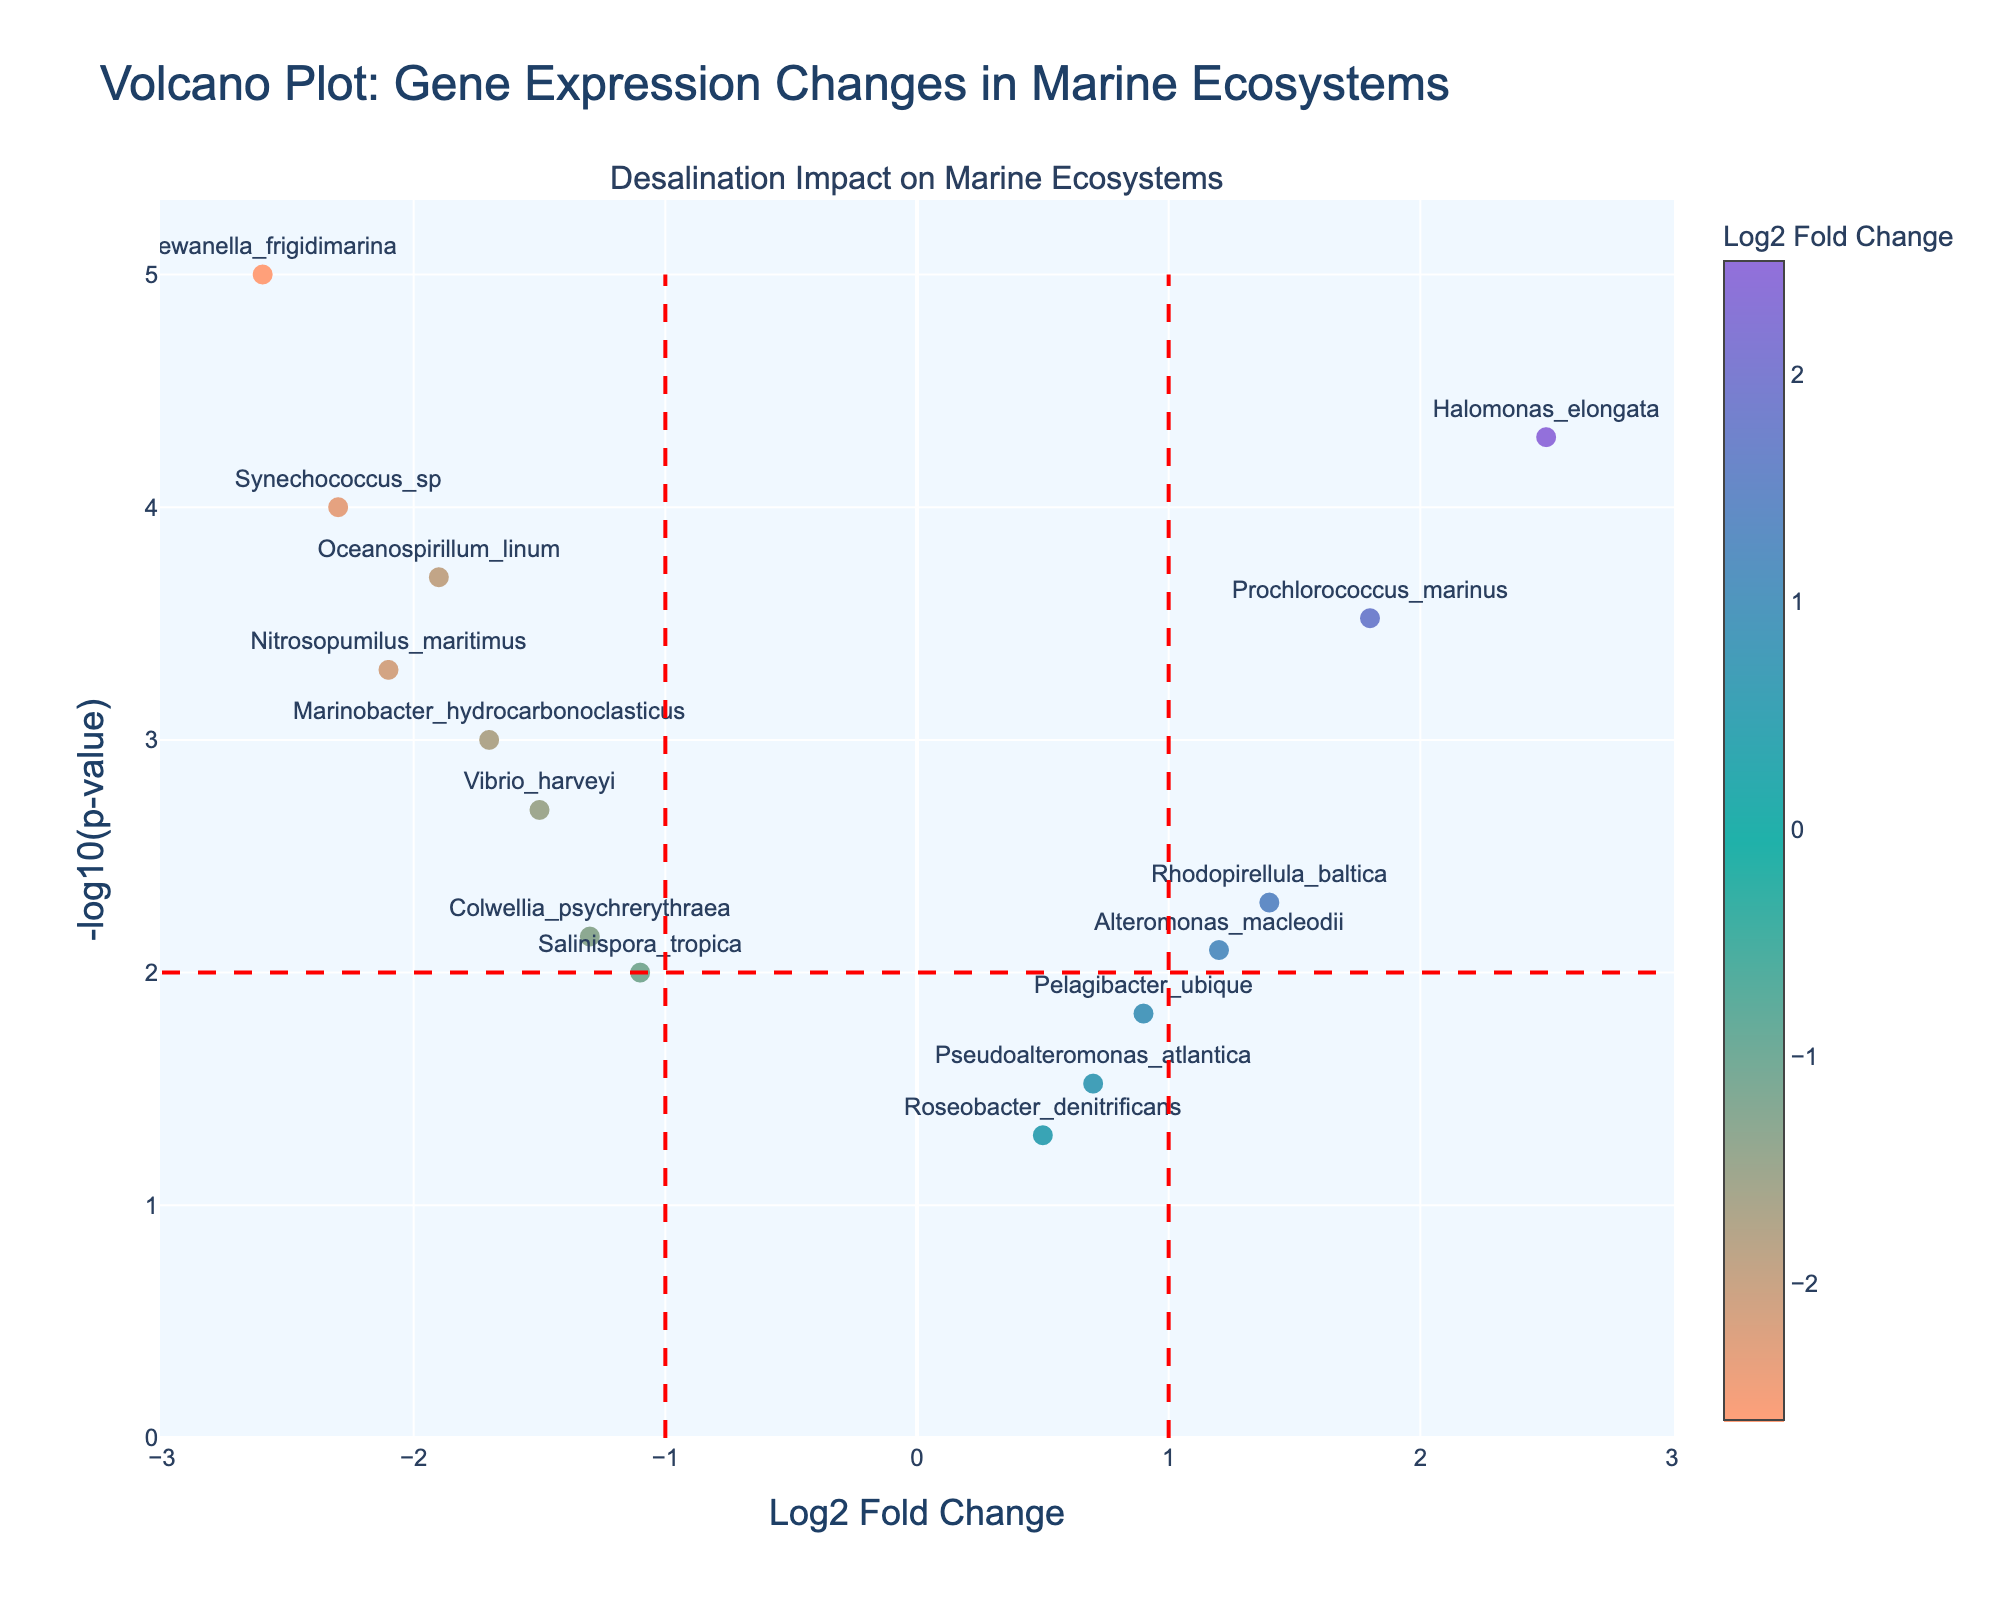How many genes show significant change (p-value < 0.05)? Count the number of points below -log10(p-value) = 1.3 on the y-axis.
Answer: 13 What is the title of the figure? Read the main title of the plot.
Answer: Volcano Plot: Gene Expression Changes in Marine Ecosystems Which gene has the highest Log2 Fold Change? Identify the point farthest to the right on the x-axis.
Answer: Halomonas_elongata Which gene has the lowest p-value? Find the point with the highest -log10(p-value) value on the y-axis.
Answer: Shewanella_frigidimarina How many genes have a Log2 Fold Change less than -1? Count the number of points to the left of the line x = -1.
Answer: 7 Compare the Log2 Fold Change of Synechococcus_sp and Prochlorococcus_marinus. Which one is larger? Synechococcus_sp is at -2.3, and Prochlorococcus_marinus is at 1.8, so Prochlorococcus_marinus is larger.
Answer: Prochlorococcus_marinus What is the range of -log10(p-value) for the genes displayed? Identify the minimum and maximum values on the y-axis and calculate the range: from the base value to the highest point.
Answer: 0 to around 5 Which genes have both a Log2 Fold Change greater than 1 and a p-value less than 0.01? Look for points to the right of x = 1 and below -log10(p-value) = 2 on the y-axis.
Answer: Halomonas_elongata, Prochlorococcus_marinus, Rhodopirellula_baltica What does the color of a marker represent in the plot? The color corresponds to the Log2 Fold Change value, based on the color bar.
Answer: Log2 Fold Change What does the figure reveal about the impact of the desalination plant on Shewanella_frigidimarina? Shewanella_frigidimarina shows a highly significant and large negative Log2 Fold Change, indicating a strong adverse impact.
Answer: Strong adverse impact 